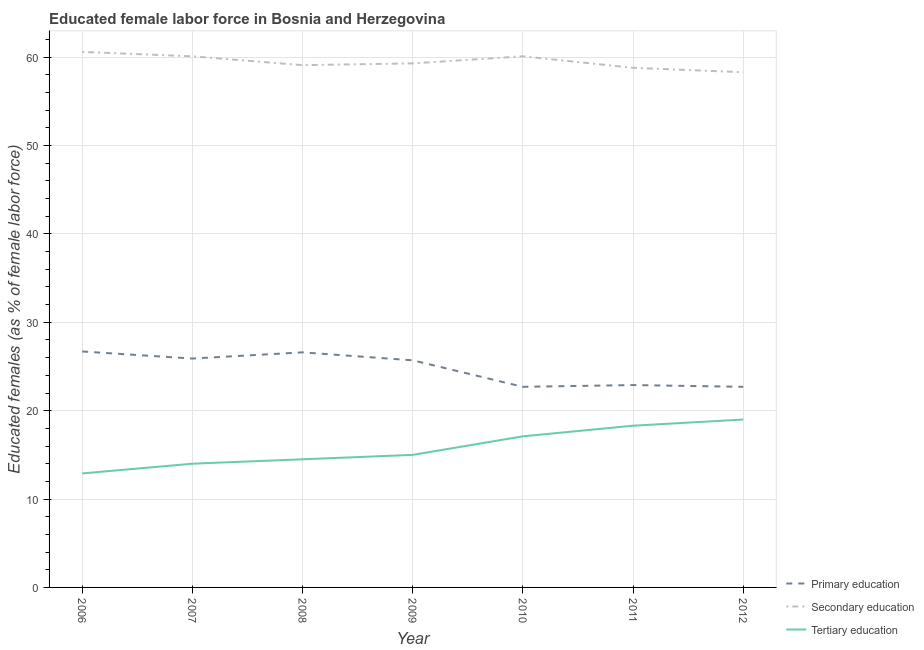Does the line corresponding to percentage of female labor force who received secondary education intersect with the line corresponding to percentage of female labor force who received primary education?
Your answer should be compact. No. What is the percentage of female labor force who received primary education in 2009?
Offer a very short reply. 25.7. Across all years, what is the maximum percentage of female labor force who received primary education?
Your answer should be very brief. 26.7. Across all years, what is the minimum percentage of female labor force who received secondary education?
Keep it short and to the point. 58.3. In which year was the percentage of female labor force who received tertiary education maximum?
Your response must be concise. 2012. In which year was the percentage of female labor force who received primary education minimum?
Ensure brevity in your answer.  2010. What is the total percentage of female labor force who received secondary education in the graph?
Provide a short and direct response. 416.3. What is the difference between the percentage of female labor force who received tertiary education in 2011 and that in 2012?
Make the answer very short. -0.7. What is the difference between the percentage of female labor force who received primary education in 2012 and the percentage of female labor force who received secondary education in 2010?
Your response must be concise. -37.4. What is the average percentage of female labor force who received secondary education per year?
Make the answer very short. 59.47. In the year 2012, what is the difference between the percentage of female labor force who received primary education and percentage of female labor force who received secondary education?
Provide a succinct answer. -35.6. In how many years, is the percentage of female labor force who received tertiary education greater than 24 %?
Provide a succinct answer. 0. What is the ratio of the percentage of female labor force who received primary education in 2007 to that in 2011?
Give a very brief answer. 1.13. Is the percentage of female labor force who received tertiary education in 2010 less than that in 2011?
Give a very brief answer. Yes. What is the difference between the highest and the lowest percentage of female labor force who received tertiary education?
Make the answer very short. 6.1. Is it the case that in every year, the sum of the percentage of female labor force who received primary education and percentage of female labor force who received secondary education is greater than the percentage of female labor force who received tertiary education?
Make the answer very short. Yes. Does the percentage of female labor force who received tertiary education monotonically increase over the years?
Offer a terse response. Yes. Is the percentage of female labor force who received secondary education strictly greater than the percentage of female labor force who received tertiary education over the years?
Offer a very short reply. Yes. Is the percentage of female labor force who received tertiary education strictly less than the percentage of female labor force who received primary education over the years?
Provide a succinct answer. Yes. How many lines are there?
Keep it short and to the point. 3. How many years are there in the graph?
Keep it short and to the point. 7. What is the difference between two consecutive major ticks on the Y-axis?
Your answer should be very brief. 10. Does the graph contain grids?
Your answer should be compact. Yes. What is the title of the graph?
Provide a short and direct response. Educated female labor force in Bosnia and Herzegovina. Does "Transport" appear as one of the legend labels in the graph?
Provide a short and direct response. No. What is the label or title of the Y-axis?
Provide a short and direct response. Educated females (as % of female labor force). What is the Educated females (as % of female labor force) in Primary education in 2006?
Provide a short and direct response. 26.7. What is the Educated females (as % of female labor force) of Secondary education in 2006?
Make the answer very short. 60.6. What is the Educated females (as % of female labor force) of Tertiary education in 2006?
Provide a short and direct response. 12.9. What is the Educated females (as % of female labor force) in Primary education in 2007?
Provide a short and direct response. 25.9. What is the Educated females (as % of female labor force) in Secondary education in 2007?
Keep it short and to the point. 60.1. What is the Educated females (as % of female labor force) of Tertiary education in 2007?
Offer a very short reply. 14. What is the Educated females (as % of female labor force) of Primary education in 2008?
Offer a terse response. 26.6. What is the Educated females (as % of female labor force) of Secondary education in 2008?
Your response must be concise. 59.1. What is the Educated females (as % of female labor force) of Tertiary education in 2008?
Provide a succinct answer. 14.5. What is the Educated females (as % of female labor force) of Primary education in 2009?
Your answer should be compact. 25.7. What is the Educated females (as % of female labor force) in Secondary education in 2009?
Your response must be concise. 59.3. What is the Educated females (as % of female labor force) in Primary education in 2010?
Make the answer very short. 22.7. What is the Educated females (as % of female labor force) of Secondary education in 2010?
Offer a very short reply. 60.1. What is the Educated females (as % of female labor force) in Tertiary education in 2010?
Provide a short and direct response. 17.1. What is the Educated females (as % of female labor force) of Primary education in 2011?
Make the answer very short. 22.9. What is the Educated females (as % of female labor force) in Secondary education in 2011?
Provide a short and direct response. 58.8. What is the Educated females (as % of female labor force) of Tertiary education in 2011?
Offer a very short reply. 18.3. What is the Educated females (as % of female labor force) of Primary education in 2012?
Ensure brevity in your answer.  22.7. What is the Educated females (as % of female labor force) of Secondary education in 2012?
Offer a very short reply. 58.3. Across all years, what is the maximum Educated females (as % of female labor force) in Primary education?
Your answer should be compact. 26.7. Across all years, what is the maximum Educated females (as % of female labor force) of Secondary education?
Your answer should be very brief. 60.6. Across all years, what is the minimum Educated females (as % of female labor force) of Primary education?
Offer a terse response. 22.7. Across all years, what is the minimum Educated females (as % of female labor force) in Secondary education?
Offer a very short reply. 58.3. Across all years, what is the minimum Educated females (as % of female labor force) of Tertiary education?
Keep it short and to the point. 12.9. What is the total Educated females (as % of female labor force) of Primary education in the graph?
Offer a terse response. 173.2. What is the total Educated females (as % of female labor force) of Secondary education in the graph?
Your answer should be compact. 416.3. What is the total Educated females (as % of female labor force) in Tertiary education in the graph?
Your answer should be very brief. 110.8. What is the difference between the Educated females (as % of female labor force) of Secondary education in 2006 and that in 2007?
Offer a very short reply. 0.5. What is the difference between the Educated females (as % of female labor force) in Tertiary education in 2006 and that in 2007?
Provide a succinct answer. -1.1. What is the difference between the Educated females (as % of female labor force) in Secondary education in 2006 and that in 2008?
Provide a succinct answer. 1.5. What is the difference between the Educated females (as % of female labor force) of Tertiary education in 2006 and that in 2009?
Your answer should be very brief. -2.1. What is the difference between the Educated females (as % of female labor force) in Primary education in 2006 and that in 2010?
Ensure brevity in your answer.  4. What is the difference between the Educated females (as % of female labor force) in Secondary education in 2006 and that in 2010?
Provide a short and direct response. 0.5. What is the difference between the Educated females (as % of female labor force) in Tertiary education in 2006 and that in 2010?
Provide a short and direct response. -4.2. What is the difference between the Educated females (as % of female labor force) in Secondary education in 2006 and that in 2012?
Provide a succinct answer. 2.3. What is the difference between the Educated females (as % of female labor force) in Tertiary education in 2006 and that in 2012?
Ensure brevity in your answer.  -6.1. What is the difference between the Educated females (as % of female labor force) of Primary education in 2007 and that in 2008?
Offer a very short reply. -0.7. What is the difference between the Educated females (as % of female labor force) in Secondary education in 2007 and that in 2008?
Offer a terse response. 1. What is the difference between the Educated females (as % of female labor force) in Tertiary education in 2007 and that in 2008?
Give a very brief answer. -0.5. What is the difference between the Educated females (as % of female labor force) of Primary education in 2007 and that in 2009?
Offer a terse response. 0.2. What is the difference between the Educated females (as % of female labor force) of Tertiary education in 2007 and that in 2009?
Give a very brief answer. -1. What is the difference between the Educated females (as % of female labor force) in Secondary education in 2007 and that in 2010?
Provide a short and direct response. 0. What is the difference between the Educated females (as % of female labor force) of Tertiary education in 2007 and that in 2012?
Your answer should be very brief. -5. What is the difference between the Educated females (as % of female labor force) of Secondary education in 2008 and that in 2009?
Your response must be concise. -0.2. What is the difference between the Educated females (as % of female labor force) of Tertiary education in 2008 and that in 2010?
Offer a very short reply. -2.6. What is the difference between the Educated females (as % of female labor force) in Primary education in 2008 and that in 2011?
Offer a terse response. 3.7. What is the difference between the Educated females (as % of female labor force) of Secondary education in 2008 and that in 2011?
Your response must be concise. 0.3. What is the difference between the Educated females (as % of female labor force) of Tertiary education in 2008 and that in 2011?
Keep it short and to the point. -3.8. What is the difference between the Educated females (as % of female labor force) in Primary education in 2008 and that in 2012?
Offer a very short reply. 3.9. What is the difference between the Educated females (as % of female labor force) of Secondary education in 2008 and that in 2012?
Your answer should be compact. 0.8. What is the difference between the Educated females (as % of female labor force) of Tertiary education in 2008 and that in 2012?
Provide a short and direct response. -4.5. What is the difference between the Educated females (as % of female labor force) of Tertiary education in 2009 and that in 2010?
Make the answer very short. -2.1. What is the difference between the Educated females (as % of female labor force) of Secondary education in 2009 and that in 2011?
Offer a terse response. 0.5. What is the difference between the Educated females (as % of female labor force) of Primary education in 2009 and that in 2012?
Provide a succinct answer. 3. What is the difference between the Educated females (as % of female labor force) of Secondary education in 2009 and that in 2012?
Your answer should be very brief. 1. What is the difference between the Educated females (as % of female labor force) in Secondary education in 2010 and that in 2011?
Provide a short and direct response. 1.3. What is the difference between the Educated females (as % of female labor force) in Tertiary education in 2010 and that in 2011?
Ensure brevity in your answer.  -1.2. What is the difference between the Educated females (as % of female labor force) of Secondary education in 2010 and that in 2012?
Provide a succinct answer. 1.8. What is the difference between the Educated females (as % of female labor force) in Tertiary education in 2010 and that in 2012?
Keep it short and to the point. -1.9. What is the difference between the Educated females (as % of female labor force) of Primary education in 2011 and that in 2012?
Offer a very short reply. 0.2. What is the difference between the Educated females (as % of female labor force) of Primary education in 2006 and the Educated females (as % of female labor force) of Secondary education in 2007?
Provide a short and direct response. -33.4. What is the difference between the Educated females (as % of female labor force) in Secondary education in 2006 and the Educated females (as % of female labor force) in Tertiary education in 2007?
Provide a short and direct response. 46.6. What is the difference between the Educated females (as % of female labor force) in Primary education in 2006 and the Educated females (as % of female labor force) in Secondary education in 2008?
Keep it short and to the point. -32.4. What is the difference between the Educated females (as % of female labor force) of Secondary education in 2006 and the Educated females (as % of female labor force) of Tertiary education in 2008?
Provide a succinct answer. 46.1. What is the difference between the Educated females (as % of female labor force) in Primary education in 2006 and the Educated females (as % of female labor force) in Secondary education in 2009?
Your response must be concise. -32.6. What is the difference between the Educated females (as % of female labor force) of Secondary education in 2006 and the Educated females (as % of female labor force) of Tertiary education in 2009?
Keep it short and to the point. 45.6. What is the difference between the Educated females (as % of female labor force) of Primary education in 2006 and the Educated females (as % of female labor force) of Secondary education in 2010?
Your answer should be very brief. -33.4. What is the difference between the Educated females (as % of female labor force) of Secondary education in 2006 and the Educated females (as % of female labor force) of Tertiary education in 2010?
Keep it short and to the point. 43.5. What is the difference between the Educated females (as % of female labor force) of Primary education in 2006 and the Educated females (as % of female labor force) of Secondary education in 2011?
Keep it short and to the point. -32.1. What is the difference between the Educated females (as % of female labor force) of Secondary education in 2006 and the Educated females (as % of female labor force) of Tertiary education in 2011?
Your answer should be compact. 42.3. What is the difference between the Educated females (as % of female labor force) of Primary education in 2006 and the Educated females (as % of female labor force) of Secondary education in 2012?
Ensure brevity in your answer.  -31.6. What is the difference between the Educated females (as % of female labor force) of Primary education in 2006 and the Educated females (as % of female labor force) of Tertiary education in 2012?
Provide a succinct answer. 7.7. What is the difference between the Educated females (as % of female labor force) of Secondary education in 2006 and the Educated females (as % of female labor force) of Tertiary education in 2012?
Offer a terse response. 41.6. What is the difference between the Educated females (as % of female labor force) of Primary education in 2007 and the Educated females (as % of female labor force) of Secondary education in 2008?
Ensure brevity in your answer.  -33.2. What is the difference between the Educated females (as % of female labor force) of Secondary education in 2007 and the Educated females (as % of female labor force) of Tertiary education in 2008?
Provide a succinct answer. 45.6. What is the difference between the Educated females (as % of female labor force) in Primary education in 2007 and the Educated females (as % of female labor force) in Secondary education in 2009?
Give a very brief answer. -33.4. What is the difference between the Educated females (as % of female labor force) of Primary education in 2007 and the Educated females (as % of female labor force) of Tertiary education in 2009?
Offer a terse response. 10.9. What is the difference between the Educated females (as % of female labor force) in Secondary education in 2007 and the Educated females (as % of female labor force) in Tertiary education in 2009?
Provide a succinct answer. 45.1. What is the difference between the Educated females (as % of female labor force) of Primary education in 2007 and the Educated females (as % of female labor force) of Secondary education in 2010?
Keep it short and to the point. -34.2. What is the difference between the Educated females (as % of female labor force) in Primary education in 2007 and the Educated females (as % of female labor force) in Secondary education in 2011?
Provide a short and direct response. -32.9. What is the difference between the Educated females (as % of female labor force) in Primary education in 2007 and the Educated females (as % of female labor force) in Tertiary education in 2011?
Give a very brief answer. 7.6. What is the difference between the Educated females (as % of female labor force) in Secondary education in 2007 and the Educated females (as % of female labor force) in Tertiary education in 2011?
Your response must be concise. 41.8. What is the difference between the Educated females (as % of female labor force) in Primary education in 2007 and the Educated females (as % of female labor force) in Secondary education in 2012?
Your answer should be compact. -32.4. What is the difference between the Educated females (as % of female labor force) of Secondary education in 2007 and the Educated females (as % of female labor force) of Tertiary education in 2012?
Give a very brief answer. 41.1. What is the difference between the Educated females (as % of female labor force) in Primary education in 2008 and the Educated females (as % of female labor force) in Secondary education in 2009?
Offer a terse response. -32.7. What is the difference between the Educated females (as % of female labor force) in Secondary education in 2008 and the Educated females (as % of female labor force) in Tertiary education in 2009?
Provide a short and direct response. 44.1. What is the difference between the Educated females (as % of female labor force) in Primary education in 2008 and the Educated females (as % of female labor force) in Secondary education in 2010?
Offer a very short reply. -33.5. What is the difference between the Educated females (as % of female labor force) in Secondary education in 2008 and the Educated females (as % of female labor force) in Tertiary education in 2010?
Your response must be concise. 42. What is the difference between the Educated females (as % of female labor force) of Primary education in 2008 and the Educated females (as % of female labor force) of Secondary education in 2011?
Provide a short and direct response. -32.2. What is the difference between the Educated females (as % of female labor force) in Primary education in 2008 and the Educated females (as % of female labor force) in Tertiary education in 2011?
Provide a succinct answer. 8.3. What is the difference between the Educated females (as % of female labor force) of Secondary education in 2008 and the Educated females (as % of female labor force) of Tertiary education in 2011?
Provide a succinct answer. 40.8. What is the difference between the Educated females (as % of female labor force) in Primary education in 2008 and the Educated females (as % of female labor force) in Secondary education in 2012?
Keep it short and to the point. -31.7. What is the difference between the Educated females (as % of female labor force) in Secondary education in 2008 and the Educated females (as % of female labor force) in Tertiary education in 2012?
Make the answer very short. 40.1. What is the difference between the Educated females (as % of female labor force) in Primary education in 2009 and the Educated females (as % of female labor force) in Secondary education in 2010?
Make the answer very short. -34.4. What is the difference between the Educated females (as % of female labor force) of Primary education in 2009 and the Educated females (as % of female labor force) of Tertiary education in 2010?
Your answer should be very brief. 8.6. What is the difference between the Educated females (as % of female labor force) of Secondary education in 2009 and the Educated females (as % of female labor force) of Tertiary education in 2010?
Provide a short and direct response. 42.2. What is the difference between the Educated females (as % of female labor force) in Primary education in 2009 and the Educated females (as % of female labor force) in Secondary education in 2011?
Your answer should be compact. -33.1. What is the difference between the Educated females (as % of female labor force) in Primary education in 2009 and the Educated females (as % of female labor force) in Secondary education in 2012?
Offer a terse response. -32.6. What is the difference between the Educated females (as % of female labor force) of Primary education in 2009 and the Educated females (as % of female labor force) of Tertiary education in 2012?
Your answer should be compact. 6.7. What is the difference between the Educated females (as % of female labor force) of Secondary education in 2009 and the Educated females (as % of female labor force) of Tertiary education in 2012?
Make the answer very short. 40.3. What is the difference between the Educated females (as % of female labor force) in Primary education in 2010 and the Educated females (as % of female labor force) in Secondary education in 2011?
Make the answer very short. -36.1. What is the difference between the Educated females (as % of female labor force) in Primary education in 2010 and the Educated females (as % of female labor force) in Tertiary education in 2011?
Offer a terse response. 4.4. What is the difference between the Educated females (as % of female labor force) of Secondary education in 2010 and the Educated females (as % of female labor force) of Tertiary education in 2011?
Keep it short and to the point. 41.8. What is the difference between the Educated females (as % of female labor force) of Primary education in 2010 and the Educated females (as % of female labor force) of Secondary education in 2012?
Ensure brevity in your answer.  -35.6. What is the difference between the Educated females (as % of female labor force) in Secondary education in 2010 and the Educated females (as % of female labor force) in Tertiary education in 2012?
Offer a terse response. 41.1. What is the difference between the Educated females (as % of female labor force) in Primary education in 2011 and the Educated females (as % of female labor force) in Secondary education in 2012?
Keep it short and to the point. -35.4. What is the difference between the Educated females (as % of female labor force) in Secondary education in 2011 and the Educated females (as % of female labor force) in Tertiary education in 2012?
Provide a short and direct response. 39.8. What is the average Educated females (as % of female labor force) in Primary education per year?
Your response must be concise. 24.74. What is the average Educated females (as % of female labor force) of Secondary education per year?
Provide a short and direct response. 59.47. What is the average Educated females (as % of female labor force) of Tertiary education per year?
Your response must be concise. 15.83. In the year 2006, what is the difference between the Educated females (as % of female labor force) in Primary education and Educated females (as % of female labor force) in Secondary education?
Provide a short and direct response. -33.9. In the year 2006, what is the difference between the Educated females (as % of female labor force) in Secondary education and Educated females (as % of female labor force) in Tertiary education?
Offer a terse response. 47.7. In the year 2007, what is the difference between the Educated females (as % of female labor force) of Primary education and Educated females (as % of female labor force) of Secondary education?
Offer a terse response. -34.2. In the year 2007, what is the difference between the Educated females (as % of female labor force) of Primary education and Educated females (as % of female labor force) of Tertiary education?
Offer a terse response. 11.9. In the year 2007, what is the difference between the Educated females (as % of female labor force) of Secondary education and Educated females (as % of female labor force) of Tertiary education?
Give a very brief answer. 46.1. In the year 2008, what is the difference between the Educated females (as % of female labor force) of Primary education and Educated females (as % of female labor force) of Secondary education?
Provide a succinct answer. -32.5. In the year 2008, what is the difference between the Educated females (as % of female labor force) of Secondary education and Educated females (as % of female labor force) of Tertiary education?
Make the answer very short. 44.6. In the year 2009, what is the difference between the Educated females (as % of female labor force) in Primary education and Educated females (as % of female labor force) in Secondary education?
Offer a terse response. -33.6. In the year 2009, what is the difference between the Educated females (as % of female labor force) in Secondary education and Educated females (as % of female labor force) in Tertiary education?
Make the answer very short. 44.3. In the year 2010, what is the difference between the Educated females (as % of female labor force) in Primary education and Educated females (as % of female labor force) in Secondary education?
Provide a short and direct response. -37.4. In the year 2010, what is the difference between the Educated females (as % of female labor force) of Secondary education and Educated females (as % of female labor force) of Tertiary education?
Provide a succinct answer. 43. In the year 2011, what is the difference between the Educated females (as % of female labor force) in Primary education and Educated females (as % of female labor force) in Secondary education?
Provide a succinct answer. -35.9. In the year 2011, what is the difference between the Educated females (as % of female labor force) of Secondary education and Educated females (as % of female labor force) of Tertiary education?
Your answer should be very brief. 40.5. In the year 2012, what is the difference between the Educated females (as % of female labor force) in Primary education and Educated females (as % of female labor force) in Secondary education?
Keep it short and to the point. -35.6. In the year 2012, what is the difference between the Educated females (as % of female labor force) in Secondary education and Educated females (as % of female labor force) in Tertiary education?
Provide a short and direct response. 39.3. What is the ratio of the Educated females (as % of female labor force) in Primary education in 2006 to that in 2007?
Keep it short and to the point. 1.03. What is the ratio of the Educated females (as % of female labor force) in Secondary education in 2006 to that in 2007?
Offer a terse response. 1.01. What is the ratio of the Educated females (as % of female labor force) of Tertiary education in 2006 to that in 2007?
Your answer should be compact. 0.92. What is the ratio of the Educated females (as % of female labor force) in Secondary education in 2006 to that in 2008?
Make the answer very short. 1.03. What is the ratio of the Educated females (as % of female labor force) of Tertiary education in 2006 to that in 2008?
Your response must be concise. 0.89. What is the ratio of the Educated females (as % of female labor force) of Primary education in 2006 to that in 2009?
Ensure brevity in your answer.  1.04. What is the ratio of the Educated females (as % of female labor force) in Secondary education in 2006 to that in 2009?
Provide a succinct answer. 1.02. What is the ratio of the Educated females (as % of female labor force) of Tertiary education in 2006 to that in 2009?
Offer a very short reply. 0.86. What is the ratio of the Educated females (as % of female labor force) in Primary education in 2006 to that in 2010?
Provide a succinct answer. 1.18. What is the ratio of the Educated females (as % of female labor force) of Secondary education in 2006 to that in 2010?
Offer a very short reply. 1.01. What is the ratio of the Educated females (as % of female labor force) in Tertiary education in 2006 to that in 2010?
Your answer should be very brief. 0.75. What is the ratio of the Educated females (as % of female labor force) in Primary education in 2006 to that in 2011?
Keep it short and to the point. 1.17. What is the ratio of the Educated females (as % of female labor force) in Secondary education in 2006 to that in 2011?
Ensure brevity in your answer.  1.03. What is the ratio of the Educated females (as % of female labor force) of Tertiary education in 2006 to that in 2011?
Give a very brief answer. 0.7. What is the ratio of the Educated females (as % of female labor force) of Primary education in 2006 to that in 2012?
Ensure brevity in your answer.  1.18. What is the ratio of the Educated females (as % of female labor force) in Secondary education in 2006 to that in 2012?
Your answer should be compact. 1.04. What is the ratio of the Educated females (as % of female labor force) in Tertiary education in 2006 to that in 2012?
Offer a terse response. 0.68. What is the ratio of the Educated females (as % of female labor force) in Primary education in 2007 to that in 2008?
Give a very brief answer. 0.97. What is the ratio of the Educated females (as % of female labor force) of Secondary education in 2007 to that in 2008?
Keep it short and to the point. 1.02. What is the ratio of the Educated females (as % of female labor force) of Tertiary education in 2007 to that in 2008?
Make the answer very short. 0.97. What is the ratio of the Educated females (as % of female labor force) of Primary education in 2007 to that in 2009?
Keep it short and to the point. 1.01. What is the ratio of the Educated females (as % of female labor force) in Secondary education in 2007 to that in 2009?
Keep it short and to the point. 1.01. What is the ratio of the Educated females (as % of female labor force) of Tertiary education in 2007 to that in 2009?
Provide a succinct answer. 0.93. What is the ratio of the Educated females (as % of female labor force) in Primary education in 2007 to that in 2010?
Make the answer very short. 1.14. What is the ratio of the Educated females (as % of female labor force) in Tertiary education in 2007 to that in 2010?
Give a very brief answer. 0.82. What is the ratio of the Educated females (as % of female labor force) of Primary education in 2007 to that in 2011?
Your response must be concise. 1.13. What is the ratio of the Educated females (as % of female labor force) in Secondary education in 2007 to that in 2011?
Make the answer very short. 1.02. What is the ratio of the Educated females (as % of female labor force) of Tertiary education in 2007 to that in 2011?
Ensure brevity in your answer.  0.77. What is the ratio of the Educated females (as % of female labor force) in Primary education in 2007 to that in 2012?
Provide a short and direct response. 1.14. What is the ratio of the Educated females (as % of female labor force) in Secondary education in 2007 to that in 2012?
Your answer should be very brief. 1.03. What is the ratio of the Educated females (as % of female labor force) in Tertiary education in 2007 to that in 2012?
Your response must be concise. 0.74. What is the ratio of the Educated females (as % of female labor force) of Primary education in 2008 to that in 2009?
Provide a short and direct response. 1.03. What is the ratio of the Educated females (as % of female labor force) of Secondary education in 2008 to that in 2009?
Your response must be concise. 1. What is the ratio of the Educated females (as % of female labor force) in Tertiary education in 2008 to that in 2009?
Your answer should be compact. 0.97. What is the ratio of the Educated females (as % of female labor force) in Primary education in 2008 to that in 2010?
Your answer should be very brief. 1.17. What is the ratio of the Educated females (as % of female labor force) of Secondary education in 2008 to that in 2010?
Your answer should be compact. 0.98. What is the ratio of the Educated females (as % of female labor force) in Tertiary education in 2008 to that in 2010?
Offer a terse response. 0.85. What is the ratio of the Educated females (as % of female labor force) of Primary education in 2008 to that in 2011?
Your answer should be very brief. 1.16. What is the ratio of the Educated females (as % of female labor force) of Tertiary education in 2008 to that in 2011?
Your answer should be very brief. 0.79. What is the ratio of the Educated females (as % of female labor force) of Primary education in 2008 to that in 2012?
Ensure brevity in your answer.  1.17. What is the ratio of the Educated females (as % of female labor force) of Secondary education in 2008 to that in 2012?
Your answer should be compact. 1.01. What is the ratio of the Educated females (as % of female labor force) in Tertiary education in 2008 to that in 2012?
Your answer should be very brief. 0.76. What is the ratio of the Educated females (as % of female labor force) in Primary education in 2009 to that in 2010?
Make the answer very short. 1.13. What is the ratio of the Educated females (as % of female labor force) of Secondary education in 2009 to that in 2010?
Ensure brevity in your answer.  0.99. What is the ratio of the Educated females (as % of female labor force) of Tertiary education in 2009 to that in 2010?
Your answer should be compact. 0.88. What is the ratio of the Educated females (as % of female labor force) of Primary education in 2009 to that in 2011?
Keep it short and to the point. 1.12. What is the ratio of the Educated females (as % of female labor force) of Secondary education in 2009 to that in 2011?
Keep it short and to the point. 1.01. What is the ratio of the Educated females (as % of female labor force) of Tertiary education in 2009 to that in 2011?
Provide a short and direct response. 0.82. What is the ratio of the Educated females (as % of female labor force) of Primary education in 2009 to that in 2012?
Make the answer very short. 1.13. What is the ratio of the Educated females (as % of female labor force) of Secondary education in 2009 to that in 2012?
Ensure brevity in your answer.  1.02. What is the ratio of the Educated females (as % of female labor force) of Tertiary education in 2009 to that in 2012?
Make the answer very short. 0.79. What is the ratio of the Educated females (as % of female labor force) of Secondary education in 2010 to that in 2011?
Keep it short and to the point. 1.02. What is the ratio of the Educated females (as % of female labor force) of Tertiary education in 2010 to that in 2011?
Give a very brief answer. 0.93. What is the ratio of the Educated females (as % of female labor force) in Primary education in 2010 to that in 2012?
Give a very brief answer. 1. What is the ratio of the Educated females (as % of female labor force) of Secondary education in 2010 to that in 2012?
Keep it short and to the point. 1.03. What is the ratio of the Educated females (as % of female labor force) in Tertiary education in 2010 to that in 2012?
Your answer should be compact. 0.9. What is the ratio of the Educated females (as % of female labor force) of Primary education in 2011 to that in 2012?
Make the answer very short. 1.01. What is the ratio of the Educated females (as % of female labor force) in Secondary education in 2011 to that in 2012?
Your answer should be compact. 1.01. What is the ratio of the Educated females (as % of female labor force) of Tertiary education in 2011 to that in 2012?
Your answer should be very brief. 0.96. What is the difference between the highest and the second highest Educated females (as % of female labor force) of Primary education?
Give a very brief answer. 0.1. What is the difference between the highest and the second highest Educated females (as % of female labor force) of Secondary education?
Your response must be concise. 0.5. What is the difference between the highest and the second highest Educated females (as % of female labor force) in Tertiary education?
Your answer should be compact. 0.7. What is the difference between the highest and the lowest Educated females (as % of female labor force) of Secondary education?
Keep it short and to the point. 2.3. What is the difference between the highest and the lowest Educated females (as % of female labor force) of Tertiary education?
Give a very brief answer. 6.1. 